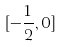Convert formula to latex. <formula><loc_0><loc_0><loc_500><loc_500>[ - \frac { 1 } { 2 } , 0 ]</formula> 